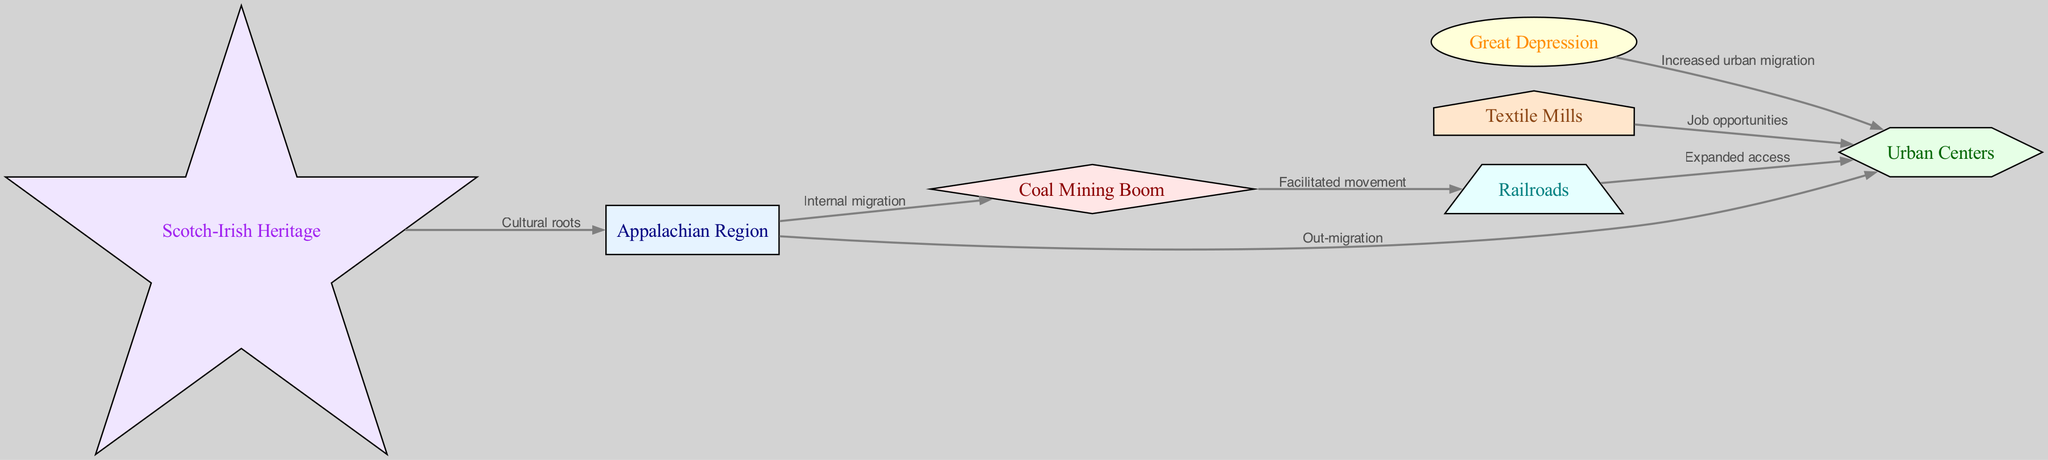What is the central geographic area depicted in the diagram? The diagram highlights the "Appalachian Region" as a key node, serving as the starting point for various migration patterns. This node connects with others, indicating its significance in the historical context of migration.
Answer: Appalachian Region How many nodes are present in the diagram? The diagram contains a total of seven nodes, each representing a different aspect related to Appalachian migration patterns and cultural influences.
Answer: 7 What industry is associated with job opportunities in urban centers? The diagram signifies that "Textile Mills" are directly linked to "Urban Centers," indicating that this industry offered job opportunities for migrants from the Appalachian Region.
Answer: Textile Mills What event increased urban migration according to the diagram? The "Great Depression" is specifically highlighted as a historical event that prompted increased urban migration, showing a direct connection to the movement towards urban centers.
Answer: Great Depression Which cultural influence is noted as having roots in the Appalachian Region? The diagram emphasizes "Scotch-Irish Heritage" as a cultural influence rooted in the Appalachian Region, illustrating the significance of this heritage in the area's cultural landscape.
Answer: Scotch-Irish Heritage What facilitated movement from the Appalachian Region to urban centers? The "Coal Mining Boom" is identified as an economic factor that facilitated movement, indicating that the demand for coal spurred migration towards opportunities in urban areas.
Answer: Coal Mining Boom What transportation network expanded access to urban centers? The diagram outlines "Railroads" as the transportation network that expanded access, illustrating how railways played a crucial role in connecting rural Appalachia with urban destinations.
Answer: Railroads Why did people migrate from the Appalachian Region to urban centers? The diagram indicates multiple factors, including job opportunities in industries like textile mills and the economic impacts of events like the Great Depression, leading to out-migration from Appalachia.
Answer: Job opportunities and economic factors 